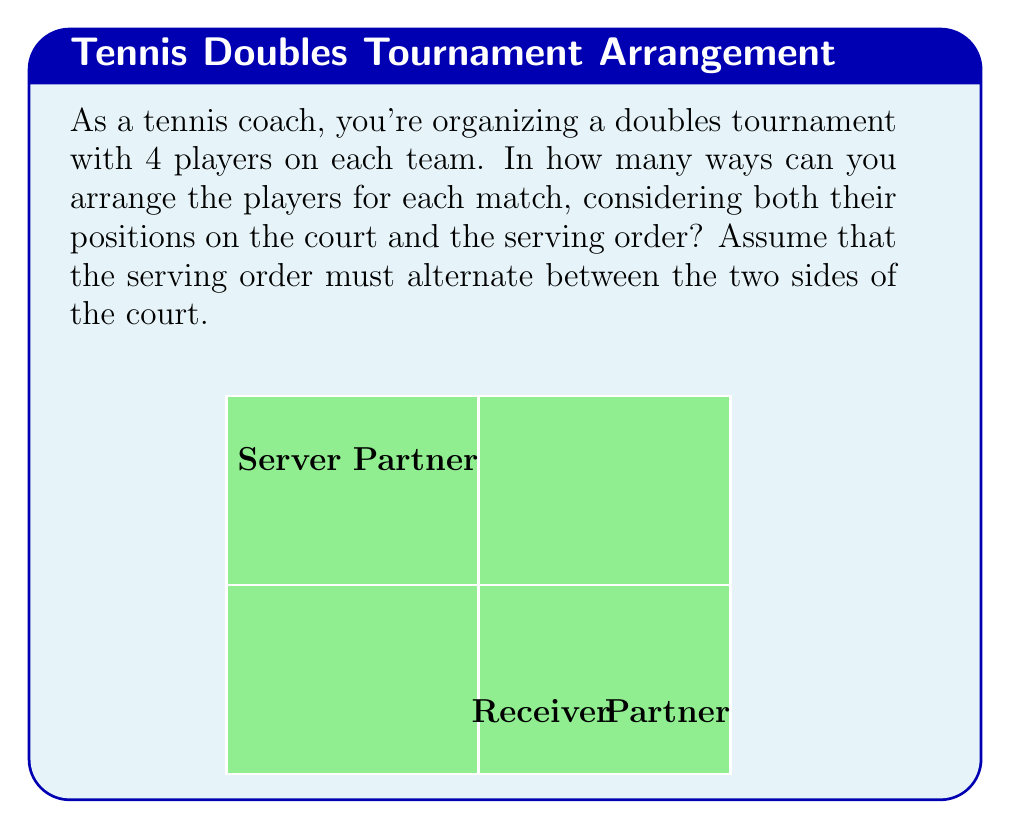Provide a solution to this math problem. Let's approach this step-by-step:

1) First, we need to consider the number of ways to arrange 4 players on the court. This is a straightforward permutation of 4, which is 4! = 24.

2) However, we also need to consider the serving order. The rules state that the serving order must alternate between the two sides of the court. This means that once we've arranged the players, we have two choices for who serves first on each side.

3) Let's break it down:
   - For the first side (top in the diagram), we have 2 choices for who serves first.
   - For the second side (bottom in the diagram), we again have 2 choices for who serves first.

4) This gives us an additional factor of 2 * 2 = 4 possibilities for the serving order.

5) By the multiplication principle, we multiply the number of court arrangements by the number of serving order possibilities:

   $$ 24 * 4 = 96 $$

6) This result, 96, is the order of the permutation group for team rotations in doubles matches under these conditions.

7) In group theory terms, this group is isomorphic to the direct product of $S_4$ (the symmetric group on 4 elements) and $C_2 \times C_2$ (the Klein four-group), which represents the serving order choices.
Answer: 96 